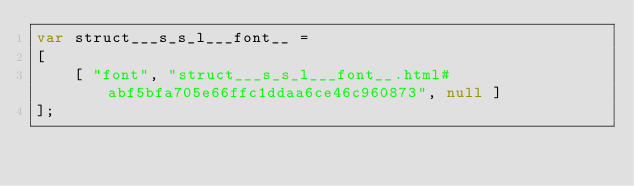Convert code to text. <code><loc_0><loc_0><loc_500><loc_500><_JavaScript_>var struct___s_s_l___font__ =
[
    [ "font", "struct___s_s_l___font__.html#abf5bfa705e66ffc1ddaa6ce46c960873", null ]
];</code> 